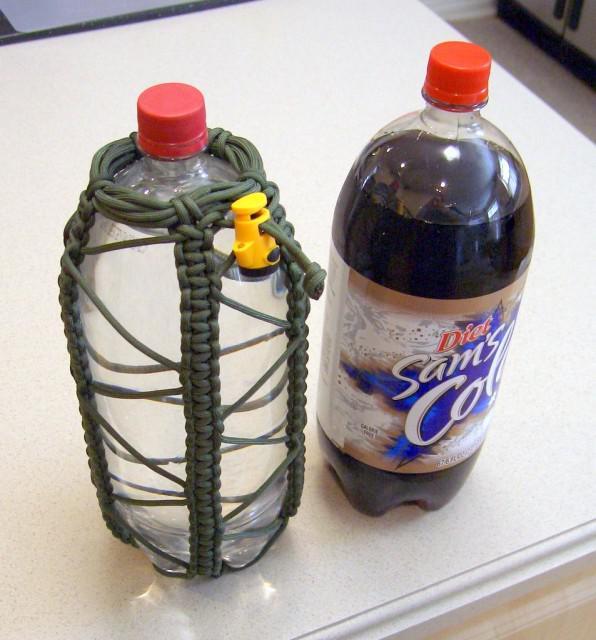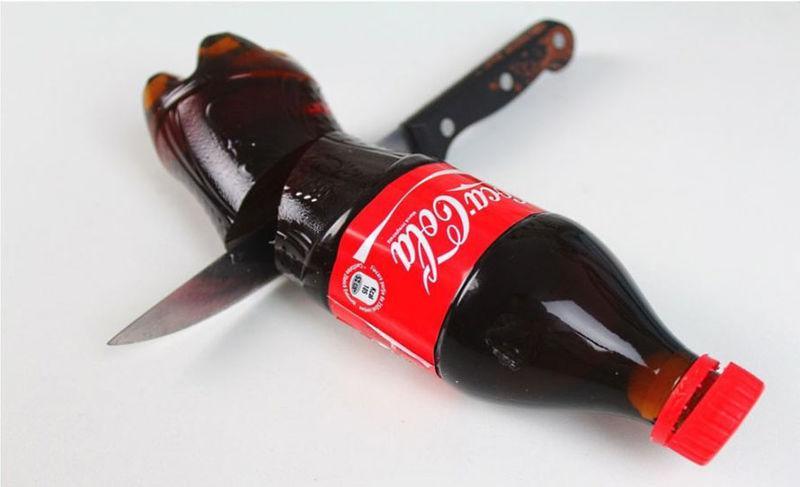The first image is the image on the left, the second image is the image on the right. For the images displayed, is the sentence "A person is holding a knife to a bottle in the image on the right." factually correct? Answer yes or no. No. The first image is the image on the left, the second image is the image on the right. Evaluate the accuracy of this statement regarding the images: "The right image shows a knife slicing through a bottle on its side, and the left image includes an upright bottle of cola.". Is it true? Answer yes or no. Yes. 